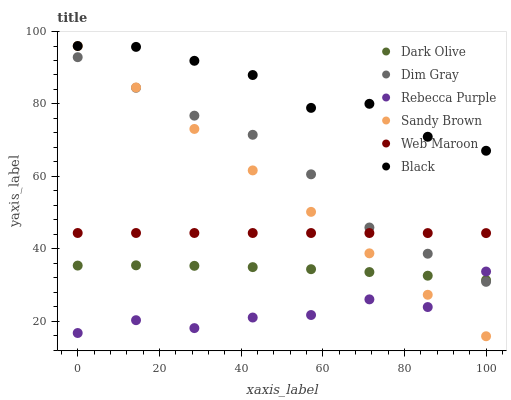Does Rebecca Purple have the minimum area under the curve?
Answer yes or no. Yes. Does Black have the maximum area under the curve?
Answer yes or no. Yes. Does Dark Olive have the minimum area under the curve?
Answer yes or no. No. Does Dark Olive have the maximum area under the curve?
Answer yes or no. No. Is Sandy Brown the smoothest?
Answer yes or no. Yes. Is Rebecca Purple the roughest?
Answer yes or no. Yes. Is Dark Olive the smoothest?
Answer yes or no. No. Is Dark Olive the roughest?
Answer yes or no. No. Does Sandy Brown have the lowest value?
Answer yes or no. Yes. Does Dark Olive have the lowest value?
Answer yes or no. No. Does Sandy Brown have the highest value?
Answer yes or no. Yes. Does Dark Olive have the highest value?
Answer yes or no. No. Is Web Maroon less than Black?
Answer yes or no. Yes. Is Web Maroon greater than Dark Olive?
Answer yes or no. Yes. Does Dim Gray intersect Rebecca Purple?
Answer yes or no. Yes. Is Dim Gray less than Rebecca Purple?
Answer yes or no. No. Is Dim Gray greater than Rebecca Purple?
Answer yes or no. No. Does Web Maroon intersect Black?
Answer yes or no. No. 